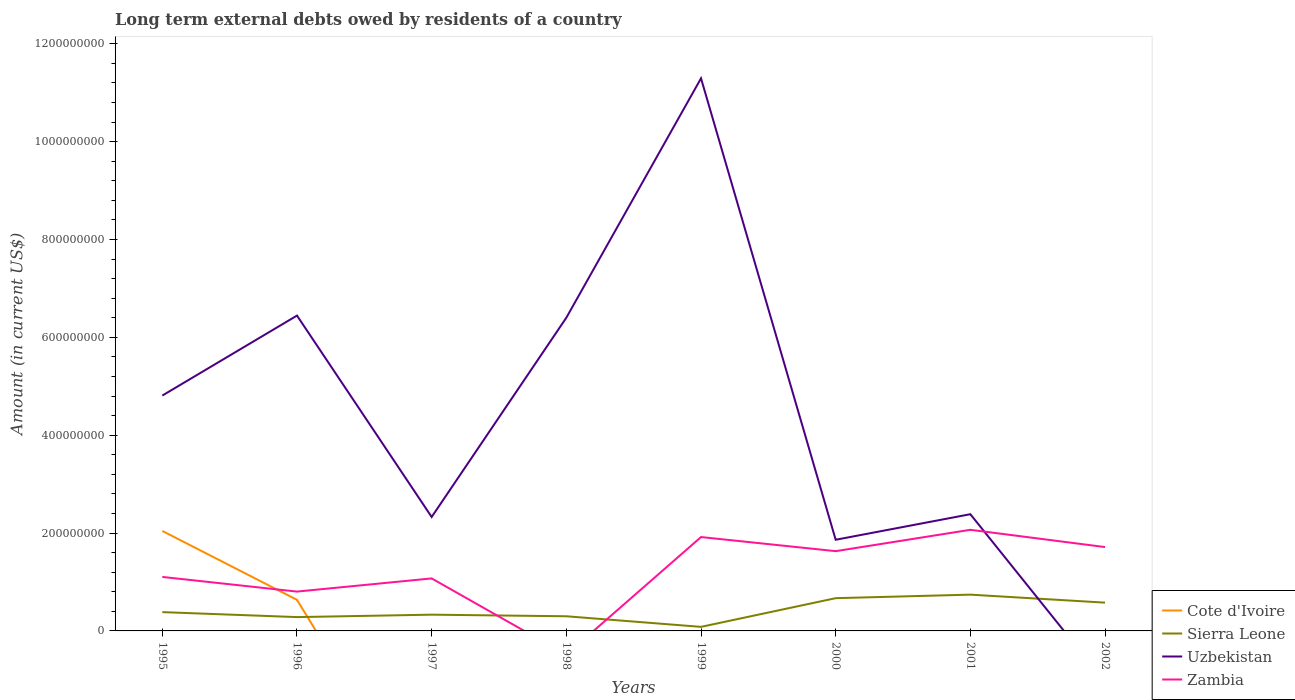How many different coloured lines are there?
Keep it short and to the point. 4. What is the total amount of long-term external debts owed by residents in Zambia in the graph?
Ensure brevity in your answer.  -1.26e+08. What is the difference between the highest and the second highest amount of long-term external debts owed by residents in Uzbekistan?
Your answer should be compact. 1.13e+09. What is the difference between the highest and the lowest amount of long-term external debts owed by residents in Zambia?
Keep it short and to the point. 4. How many lines are there?
Make the answer very short. 4. Are the values on the major ticks of Y-axis written in scientific E-notation?
Offer a very short reply. No. How are the legend labels stacked?
Provide a short and direct response. Vertical. What is the title of the graph?
Provide a short and direct response. Long term external debts owed by residents of a country. What is the label or title of the X-axis?
Offer a terse response. Years. What is the label or title of the Y-axis?
Provide a short and direct response. Amount (in current US$). What is the Amount (in current US$) in Cote d'Ivoire in 1995?
Your answer should be compact. 2.04e+08. What is the Amount (in current US$) in Sierra Leone in 1995?
Your answer should be compact. 3.84e+07. What is the Amount (in current US$) in Uzbekistan in 1995?
Give a very brief answer. 4.81e+08. What is the Amount (in current US$) of Zambia in 1995?
Your answer should be compact. 1.10e+08. What is the Amount (in current US$) of Cote d'Ivoire in 1996?
Keep it short and to the point. 6.35e+07. What is the Amount (in current US$) in Sierra Leone in 1996?
Your answer should be compact. 2.83e+07. What is the Amount (in current US$) of Uzbekistan in 1996?
Offer a terse response. 6.45e+08. What is the Amount (in current US$) of Zambia in 1996?
Offer a very short reply. 8.04e+07. What is the Amount (in current US$) in Sierra Leone in 1997?
Your answer should be compact. 3.32e+07. What is the Amount (in current US$) in Uzbekistan in 1997?
Provide a short and direct response. 2.33e+08. What is the Amount (in current US$) in Zambia in 1997?
Your answer should be compact. 1.07e+08. What is the Amount (in current US$) in Sierra Leone in 1998?
Offer a terse response. 3.00e+07. What is the Amount (in current US$) in Uzbekistan in 1998?
Ensure brevity in your answer.  6.40e+08. What is the Amount (in current US$) in Cote d'Ivoire in 1999?
Ensure brevity in your answer.  0. What is the Amount (in current US$) of Sierra Leone in 1999?
Ensure brevity in your answer.  8.29e+06. What is the Amount (in current US$) in Uzbekistan in 1999?
Your response must be concise. 1.13e+09. What is the Amount (in current US$) of Zambia in 1999?
Ensure brevity in your answer.  1.92e+08. What is the Amount (in current US$) of Cote d'Ivoire in 2000?
Offer a terse response. 0. What is the Amount (in current US$) of Sierra Leone in 2000?
Your response must be concise. 6.69e+07. What is the Amount (in current US$) in Uzbekistan in 2000?
Provide a succinct answer. 1.86e+08. What is the Amount (in current US$) of Zambia in 2000?
Keep it short and to the point. 1.63e+08. What is the Amount (in current US$) in Sierra Leone in 2001?
Provide a short and direct response. 7.41e+07. What is the Amount (in current US$) in Uzbekistan in 2001?
Keep it short and to the point. 2.39e+08. What is the Amount (in current US$) in Zambia in 2001?
Your answer should be compact. 2.07e+08. What is the Amount (in current US$) in Cote d'Ivoire in 2002?
Provide a succinct answer. 0. What is the Amount (in current US$) of Sierra Leone in 2002?
Give a very brief answer. 5.78e+07. What is the Amount (in current US$) of Uzbekistan in 2002?
Offer a very short reply. 0. What is the Amount (in current US$) of Zambia in 2002?
Offer a very short reply. 1.71e+08. Across all years, what is the maximum Amount (in current US$) of Cote d'Ivoire?
Make the answer very short. 2.04e+08. Across all years, what is the maximum Amount (in current US$) in Sierra Leone?
Offer a very short reply. 7.41e+07. Across all years, what is the maximum Amount (in current US$) in Uzbekistan?
Your response must be concise. 1.13e+09. Across all years, what is the maximum Amount (in current US$) of Zambia?
Keep it short and to the point. 2.07e+08. Across all years, what is the minimum Amount (in current US$) in Sierra Leone?
Provide a short and direct response. 8.29e+06. Across all years, what is the minimum Amount (in current US$) in Uzbekistan?
Provide a succinct answer. 0. Across all years, what is the minimum Amount (in current US$) of Zambia?
Give a very brief answer. 0. What is the total Amount (in current US$) of Cote d'Ivoire in the graph?
Provide a succinct answer. 2.68e+08. What is the total Amount (in current US$) of Sierra Leone in the graph?
Your response must be concise. 3.37e+08. What is the total Amount (in current US$) of Uzbekistan in the graph?
Your response must be concise. 3.55e+09. What is the total Amount (in current US$) in Zambia in the graph?
Your response must be concise. 1.03e+09. What is the difference between the Amount (in current US$) of Cote d'Ivoire in 1995 and that in 1996?
Keep it short and to the point. 1.41e+08. What is the difference between the Amount (in current US$) in Sierra Leone in 1995 and that in 1996?
Offer a very short reply. 1.02e+07. What is the difference between the Amount (in current US$) in Uzbekistan in 1995 and that in 1996?
Your answer should be compact. -1.63e+08. What is the difference between the Amount (in current US$) in Zambia in 1995 and that in 1996?
Your answer should be compact. 3.00e+07. What is the difference between the Amount (in current US$) in Sierra Leone in 1995 and that in 1997?
Your response must be concise. 5.22e+06. What is the difference between the Amount (in current US$) of Uzbekistan in 1995 and that in 1997?
Make the answer very short. 2.48e+08. What is the difference between the Amount (in current US$) in Zambia in 1995 and that in 1997?
Your response must be concise. 3.05e+06. What is the difference between the Amount (in current US$) of Sierra Leone in 1995 and that in 1998?
Ensure brevity in your answer.  8.46e+06. What is the difference between the Amount (in current US$) of Uzbekistan in 1995 and that in 1998?
Give a very brief answer. -1.59e+08. What is the difference between the Amount (in current US$) of Sierra Leone in 1995 and that in 1999?
Make the answer very short. 3.01e+07. What is the difference between the Amount (in current US$) of Uzbekistan in 1995 and that in 1999?
Provide a succinct answer. -6.48e+08. What is the difference between the Amount (in current US$) of Zambia in 1995 and that in 1999?
Ensure brevity in your answer.  -8.15e+07. What is the difference between the Amount (in current US$) of Sierra Leone in 1995 and that in 2000?
Offer a terse response. -2.85e+07. What is the difference between the Amount (in current US$) in Uzbekistan in 1995 and that in 2000?
Provide a succinct answer. 2.95e+08. What is the difference between the Amount (in current US$) in Zambia in 1995 and that in 2000?
Provide a short and direct response. -5.27e+07. What is the difference between the Amount (in current US$) of Sierra Leone in 1995 and that in 2001?
Your answer should be compact. -3.57e+07. What is the difference between the Amount (in current US$) in Uzbekistan in 1995 and that in 2001?
Your answer should be compact. 2.42e+08. What is the difference between the Amount (in current US$) of Zambia in 1995 and that in 2001?
Make the answer very short. -9.63e+07. What is the difference between the Amount (in current US$) in Sierra Leone in 1995 and that in 2002?
Your answer should be very brief. -1.94e+07. What is the difference between the Amount (in current US$) of Zambia in 1995 and that in 2002?
Make the answer very short. -6.10e+07. What is the difference between the Amount (in current US$) of Sierra Leone in 1996 and that in 1997?
Offer a very short reply. -4.94e+06. What is the difference between the Amount (in current US$) of Uzbekistan in 1996 and that in 1997?
Ensure brevity in your answer.  4.12e+08. What is the difference between the Amount (in current US$) in Zambia in 1996 and that in 1997?
Make the answer very short. -2.69e+07. What is the difference between the Amount (in current US$) in Sierra Leone in 1996 and that in 1998?
Provide a succinct answer. -1.71e+06. What is the difference between the Amount (in current US$) of Uzbekistan in 1996 and that in 1998?
Your response must be concise. 4.38e+06. What is the difference between the Amount (in current US$) in Sierra Leone in 1996 and that in 1999?
Offer a terse response. 2.00e+07. What is the difference between the Amount (in current US$) of Uzbekistan in 1996 and that in 1999?
Ensure brevity in your answer.  -4.85e+08. What is the difference between the Amount (in current US$) in Zambia in 1996 and that in 1999?
Give a very brief answer. -1.11e+08. What is the difference between the Amount (in current US$) in Sierra Leone in 1996 and that in 2000?
Your answer should be compact. -3.87e+07. What is the difference between the Amount (in current US$) in Uzbekistan in 1996 and that in 2000?
Keep it short and to the point. 4.58e+08. What is the difference between the Amount (in current US$) in Zambia in 1996 and that in 2000?
Your answer should be very brief. -8.26e+07. What is the difference between the Amount (in current US$) in Sierra Leone in 1996 and that in 2001?
Give a very brief answer. -4.59e+07. What is the difference between the Amount (in current US$) in Uzbekistan in 1996 and that in 2001?
Offer a terse response. 4.06e+08. What is the difference between the Amount (in current US$) in Zambia in 1996 and that in 2001?
Keep it short and to the point. -1.26e+08. What is the difference between the Amount (in current US$) in Sierra Leone in 1996 and that in 2002?
Keep it short and to the point. -2.95e+07. What is the difference between the Amount (in current US$) of Zambia in 1996 and that in 2002?
Your answer should be compact. -9.10e+07. What is the difference between the Amount (in current US$) of Sierra Leone in 1997 and that in 1998?
Provide a succinct answer. 3.24e+06. What is the difference between the Amount (in current US$) of Uzbekistan in 1997 and that in 1998?
Ensure brevity in your answer.  -4.07e+08. What is the difference between the Amount (in current US$) of Sierra Leone in 1997 and that in 1999?
Your answer should be very brief. 2.49e+07. What is the difference between the Amount (in current US$) in Uzbekistan in 1997 and that in 1999?
Your response must be concise. -8.97e+08. What is the difference between the Amount (in current US$) in Zambia in 1997 and that in 1999?
Your response must be concise. -8.45e+07. What is the difference between the Amount (in current US$) in Sierra Leone in 1997 and that in 2000?
Provide a succinct answer. -3.37e+07. What is the difference between the Amount (in current US$) in Uzbekistan in 1997 and that in 2000?
Ensure brevity in your answer.  4.66e+07. What is the difference between the Amount (in current US$) of Zambia in 1997 and that in 2000?
Make the answer very short. -5.57e+07. What is the difference between the Amount (in current US$) in Sierra Leone in 1997 and that in 2001?
Provide a short and direct response. -4.09e+07. What is the difference between the Amount (in current US$) of Uzbekistan in 1997 and that in 2001?
Keep it short and to the point. -5.69e+06. What is the difference between the Amount (in current US$) of Zambia in 1997 and that in 2001?
Provide a short and direct response. -9.94e+07. What is the difference between the Amount (in current US$) of Sierra Leone in 1997 and that in 2002?
Offer a terse response. -2.46e+07. What is the difference between the Amount (in current US$) of Zambia in 1997 and that in 2002?
Make the answer very short. -6.41e+07. What is the difference between the Amount (in current US$) of Sierra Leone in 1998 and that in 1999?
Ensure brevity in your answer.  2.17e+07. What is the difference between the Amount (in current US$) in Uzbekistan in 1998 and that in 1999?
Offer a very short reply. -4.89e+08. What is the difference between the Amount (in current US$) in Sierra Leone in 1998 and that in 2000?
Your answer should be compact. -3.70e+07. What is the difference between the Amount (in current US$) of Uzbekistan in 1998 and that in 2000?
Provide a short and direct response. 4.54e+08. What is the difference between the Amount (in current US$) in Sierra Leone in 1998 and that in 2001?
Your response must be concise. -4.42e+07. What is the difference between the Amount (in current US$) of Uzbekistan in 1998 and that in 2001?
Make the answer very short. 4.02e+08. What is the difference between the Amount (in current US$) of Sierra Leone in 1998 and that in 2002?
Your response must be concise. -2.78e+07. What is the difference between the Amount (in current US$) in Sierra Leone in 1999 and that in 2000?
Provide a short and direct response. -5.87e+07. What is the difference between the Amount (in current US$) in Uzbekistan in 1999 and that in 2000?
Offer a very short reply. 9.43e+08. What is the difference between the Amount (in current US$) of Zambia in 1999 and that in 2000?
Your answer should be very brief. 2.88e+07. What is the difference between the Amount (in current US$) in Sierra Leone in 1999 and that in 2001?
Offer a very short reply. -6.59e+07. What is the difference between the Amount (in current US$) of Uzbekistan in 1999 and that in 2001?
Keep it short and to the point. 8.91e+08. What is the difference between the Amount (in current US$) of Zambia in 1999 and that in 2001?
Provide a succinct answer. -1.48e+07. What is the difference between the Amount (in current US$) of Sierra Leone in 1999 and that in 2002?
Offer a very short reply. -4.95e+07. What is the difference between the Amount (in current US$) of Zambia in 1999 and that in 2002?
Offer a very short reply. 2.05e+07. What is the difference between the Amount (in current US$) in Sierra Leone in 2000 and that in 2001?
Provide a short and direct response. -7.21e+06. What is the difference between the Amount (in current US$) in Uzbekistan in 2000 and that in 2001?
Ensure brevity in your answer.  -5.22e+07. What is the difference between the Amount (in current US$) of Zambia in 2000 and that in 2001?
Your answer should be very brief. -4.37e+07. What is the difference between the Amount (in current US$) in Sierra Leone in 2000 and that in 2002?
Offer a terse response. 9.15e+06. What is the difference between the Amount (in current US$) in Zambia in 2000 and that in 2002?
Your answer should be very brief. -8.37e+06. What is the difference between the Amount (in current US$) in Sierra Leone in 2001 and that in 2002?
Your answer should be very brief. 1.64e+07. What is the difference between the Amount (in current US$) in Zambia in 2001 and that in 2002?
Provide a short and direct response. 3.53e+07. What is the difference between the Amount (in current US$) in Cote d'Ivoire in 1995 and the Amount (in current US$) in Sierra Leone in 1996?
Ensure brevity in your answer.  1.76e+08. What is the difference between the Amount (in current US$) of Cote d'Ivoire in 1995 and the Amount (in current US$) of Uzbekistan in 1996?
Keep it short and to the point. -4.40e+08. What is the difference between the Amount (in current US$) of Cote d'Ivoire in 1995 and the Amount (in current US$) of Zambia in 1996?
Ensure brevity in your answer.  1.24e+08. What is the difference between the Amount (in current US$) of Sierra Leone in 1995 and the Amount (in current US$) of Uzbekistan in 1996?
Offer a very short reply. -6.06e+08. What is the difference between the Amount (in current US$) in Sierra Leone in 1995 and the Amount (in current US$) in Zambia in 1996?
Offer a very short reply. -4.20e+07. What is the difference between the Amount (in current US$) of Uzbekistan in 1995 and the Amount (in current US$) of Zambia in 1996?
Ensure brevity in your answer.  4.01e+08. What is the difference between the Amount (in current US$) in Cote d'Ivoire in 1995 and the Amount (in current US$) in Sierra Leone in 1997?
Provide a short and direct response. 1.71e+08. What is the difference between the Amount (in current US$) in Cote d'Ivoire in 1995 and the Amount (in current US$) in Uzbekistan in 1997?
Provide a succinct answer. -2.85e+07. What is the difference between the Amount (in current US$) in Cote d'Ivoire in 1995 and the Amount (in current US$) in Zambia in 1997?
Your response must be concise. 9.70e+07. What is the difference between the Amount (in current US$) in Sierra Leone in 1995 and the Amount (in current US$) in Uzbekistan in 1997?
Offer a very short reply. -1.94e+08. What is the difference between the Amount (in current US$) of Sierra Leone in 1995 and the Amount (in current US$) of Zambia in 1997?
Offer a very short reply. -6.89e+07. What is the difference between the Amount (in current US$) in Uzbekistan in 1995 and the Amount (in current US$) in Zambia in 1997?
Offer a terse response. 3.74e+08. What is the difference between the Amount (in current US$) of Cote d'Ivoire in 1995 and the Amount (in current US$) of Sierra Leone in 1998?
Provide a short and direct response. 1.74e+08. What is the difference between the Amount (in current US$) of Cote d'Ivoire in 1995 and the Amount (in current US$) of Uzbekistan in 1998?
Give a very brief answer. -4.36e+08. What is the difference between the Amount (in current US$) of Sierra Leone in 1995 and the Amount (in current US$) of Uzbekistan in 1998?
Your response must be concise. -6.02e+08. What is the difference between the Amount (in current US$) of Cote d'Ivoire in 1995 and the Amount (in current US$) of Sierra Leone in 1999?
Make the answer very short. 1.96e+08. What is the difference between the Amount (in current US$) of Cote d'Ivoire in 1995 and the Amount (in current US$) of Uzbekistan in 1999?
Offer a very short reply. -9.25e+08. What is the difference between the Amount (in current US$) of Cote d'Ivoire in 1995 and the Amount (in current US$) of Zambia in 1999?
Ensure brevity in your answer.  1.25e+07. What is the difference between the Amount (in current US$) in Sierra Leone in 1995 and the Amount (in current US$) in Uzbekistan in 1999?
Offer a very short reply. -1.09e+09. What is the difference between the Amount (in current US$) of Sierra Leone in 1995 and the Amount (in current US$) of Zambia in 1999?
Provide a short and direct response. -1.53e+08. What is the difference between the Amount (in current US$) of Uzbekistan in 1995 and the Amount (in current US$) of Zambia in 1999?
Offer a terse response. 2.89e+08. What is the difference between the Amount (in current US$) of Cote d'Ivoire in 1995 and the Amount (in current US$) of Sierra Leone in 2000?
Ensure brevity in your answer.  1.37e+08. What is the difference between the Amount (in current US$) of Cote d'Ivoire in 1995 and the Amount (in current US$) of Uzbekistan in 2000?
Provide a succinct answer. 1.80e+07. What is the difference between the Amount (in current US$) of Cote d'Ivoire in 1995 and the Amount (in current US$) of Zambia in 2000?
Keep it short and to the point. 4.13e+07. What is the difference between the Amount (in current US$) in Sierra Leone in 1995 and the Amount (in current US$) in Uzbekistan in 2000?
Give a very brief answer. -1.48e+08. What is the difference between the Amount (in current US$) in Sierra Leone in 1995 and the Amount (in current US$) in Zambia in 2000?
Make the answer very short. -1.25e+08. What is the difference between the Amount (in current US$) of Uzbekistan in 1995 and the Amount (in current US$) of Zambia in 2000?
Make the answer very short. 3.18e+08. What is the difference between the Amount (in current US$) in Cote d'Ivoire in 1995 and the Amount (in current US$) in Sierra Leone in 2001?
Provide a short and direct response. 1.30e+08. What is the difference between the Amount (in current US$) of Cote d'Ivoire in 1995 and the Amount (in current US$) of Uzbekistan in 2001?
Your response must be concise. -3.42e+07. What is the difference between the Amount (in current US$) in Cote d'Ivoire in 1995 and the Amount (in current US$) in Zambia in 2001?
Your answer should be compact. -2.31e+06. What is the difference between the Amount (in current US$) in Sierra Leone in 1995 and the Amount (in current US$) in Uzbekistan in 2001?
Ensure brevity in your answer.  -2.00e+08. What is the difference between the Amount (in current US$) in Sierra Leone in 1995 and the Amount (in current US$) in Zambia in 2001?
Give a very brief answer. -1.68e+08. What is the difference between the Amount (in current US$) of Uzbekistan in 1995 and the Amount (in current US$) of Zambia in 2001?
Your answer should be compact. 2.74e+08. What is the difference between the Amount (in current US$) of Cote d'Ivoire in 1995 and the Amount (in current US$) of Sierra Leone in 2002?
Give a very brief answer. 1.47e+08. What is the difference between the Amount (in current US$) of Cote d'Ivoire in 1995 and the Amount (in current US$) of Zambia in 2002?
Your answer should be very brief. 3.30e+07. What is the difference between the Amount (in current US$) in Sierra Leone in 1995 and the Amount (in current US$) in Zambia in 2002?
Give a very brief answer. -1.33e+08. What is the difference between the Amount (in current US$) of Uzbekistan in 1995 and the Amount (in current US$) of Zambia in 2002?
Your response must be concise. 3.10e+08. What is the difference between the Amount (in current US$) in Cote d'Ivoire in 1996 and the Amount (in current US$) in Sierra Leone in 1997?
Keep it short and to the point. 3.03e+07. What is the difference between the Amount (in current US$) in Cote d'Ivoire in 1996 and the Amount (in current US$) in Uzbekistan in 1997?
Provide a succinct answer. -1.69e+08. What is the difference between the Amount (in current US$) of Cote d'Ivoire in 1996 and the Amount (in current US$) of Zambia in 1997?
Your response must be concise. -4.38e+07. What is the difference between the Amount (in current US$) in Sierra Leone in 1996 and the Amount (in current US$) in Uzbekistan in 1997?
Ensure brevity in your answer.  -2.05e+08. What is the difference between the Amount (in current US$) in Sierra Leone in 1996 and the Amount (in current US$) in Zambia in 1997?
Your response must be concise. -7.91e+07. What is the difference between the Amount (in current US$) in Uzbekistan in 1996 and the Amount (in current US$) in Zambia in 1997?
Your answer should be very brief. 5.37e+08. What is the difference between the Amount (in current US$) of Cote d'Ivoire in 1996 and the Amount (in current US$) of Sierra Leone in 1998?
Your response must be concise. 3.36e+07. What is the difference between the Amount (in current US$) of Cote d'Ivoire in 1996 and the Amount (in current US$) of Uzbekistan in 1998?
Give a very brief answer. -5.77e+08. What is the difference between the Amount (in current US$) in Sierra Leone in 1996 and the Amount (in current US$) in Uzbekistan in 1998?
Your answer should be compact. -6.12e+08. What is the difference between the Amount (in current US$) of Cote d'Ivoire in 1996 and the Amount (in current US$) of Sierra Leone in 1999?
Ensure brevity in your answer.  5.53e+07. What is the difference between the Amount (in current US$) of Cote d'Ivoire in 1996 and the Amount (in current US$) of Uzbekistan in 1999?
Your answer should be very brief. -1.07e+09. What is the difference between the Amount (in current US$) of Cote d'Ivoire in 1996 and the Amount (in current US$) of Zambia in 1999?
Your answer should be very brief. -1.28e+08. What is the difference between the Amount (in current US$) in Sierra Leone in 1996 and the Amount (in current US$) in Uzbekistan in 1999?
Provide a short and direct response. -1.10e+09. What is the difference between the Amount (in current US$) in Sierra Leone in 1996 and the Amount (in current US$) in Zambia in 1999?
Keep it short and to the point. -1.64e+08. What is the difference between the Amount (in current US$) of Uzbekistan in 1996 and the Amount (in current US$) of Zambia in 1999?
Make the answer very short. 4.53e+08. What is the difference between the Amount (in current US$) of Cote d'Ivoire in 1996 and the Amount (in current US$) of Sierra Leone in 2000?
Offer a very short reply. -3.40e+06. What is the difference between the Amount (in current US$) of Cote d'Ivoire in 1996 and the Amount (in current US$) of Uzbekistan in 2000?
Provide a short and direct response. -1.23e+08. What is the difference between the Amount (in current US$) of Cote d'Ivoire in 1996 and the Amount (in current US$) of Zambia in 2000?
Ensure brevity in your answer.  -9.95e+07. What is the difference between the Amount (in current US$) in Sierra Leone in 1996 and the Amount (in current US$) in Uzbekistan in 2000?
Offer a terse response. -1.58e+08. What is the difference between the Amount (in current US$) in Sierra Leone in 1996 and the Amount (in current US$) in Zambia in 2000?
Your answer should be compact. -1.35e+08. What is the difference between the Amount (in current US$) of Uzbekistan in 1996 and the Amount (in current US$) of Zambia in 2000?
Keep it short and to the point. 4.82e+08. What is the difference between the Amount (in current US$) in Cote d'Ivoire in 1996 and the Amount (in current US$) in Sierra Leone in 2001?
Your answer should be compact. -1.06e+07. What is the difference between the Amount (in current US$) of Cote d'Ivoire in 1996 and the Amount (in current US$) of Uzbekistan in 2001?
Your answer should be compact. -1.75e+08. What is the difference between the Amount (in current US$) of Cote d'Ivoire in 1996 and the Amount (in current US$) of Zambia in 2001?
Provide a succinct answer. -1.43e+08. What is the difference between the Amount (in current US$) of Sierra Leone in 1996 and the Amount (in current US$) of Uzbekistan in 2001?
Offer a terse response. -2.10e+08. What is the difference between the Amount (in current US$) of Sierra Leone in 1996 and the Amount (in current US$) of Zambia in 2001?
Your response must be concise. -1.78e+08. What is the difference between the Amount (in current US$) in Uzbekistan in 1996 and the Amount (in current US$) in Zambia in 2001?
Provide a succinct answer. 4.38e+08. What is the difference between the Amount (in current US$) of Cote d'Ivoire in 1996 and the Amount (in current US$) of Sierra Leone in 2002?
Keep it short and to the point. 5.75e+06. What is the difference between the Amount (in current US$) in Cote d'Ivoire in 1996 and the Amount (in current US$) in Zambia in 2002?
Give a very brief answer. -1.08e+08. What is the difference between the Amount (in current US$) of Sierra Leone in 1996 and the Amount (in current US$) of Zambia in 2002?
Make the answer very short. -1.43e+08. What is the difference between the Amount (in current US$) in Uzbekistan in 1996 and the Amount (in current US$) in Zambia in 2002?
Offer a terse response. 4.73e+08. What is the difference between the Amount (in current US$) of Sierra Leone in 1997 and the Amount (in current US$) of Uzbekistan in 1998?
Your answer should be very brief. -6.07e+08. What is the difference between the Amount (in current US$) of Sierra Leone in 1997 and the Amount (in current US$) of Uzbekistan in 1999?
Provide a short and direct response. -1.10e+09. What is the difference between the Amount (in current US$) in Sierra Leone in 1997 and the Amount (in current US$) in Zambia in 1999?
Keep it short and to the point. -1.59e+08. What is the difference between the Amount (in current US$) in Uzbekistan in 1997 and the Amount (in current US$) in Zambia in 1999?
Offer a terse response. 4.10e+07. What is the difference between the Amount (in current US$) in Sierra Leone in 1997 and the Amount (in current US$) in Uzbekistan in 2000?
Offer a very short reply. -1.53e+08. What is the difference between the Amount (in current US$) of Sierra Leone in 1997 and the Amount (in current US$) of Zambia in 2000?
Offer a terse response. -1.30e+08. What is the difference between the Amount (in current US$) of Uzbekistan in 1997 and the Amount (in current US$) of Zambia in 2000?
Your response must be concise. 6.99e+07. What is the difference between the Amount (in current US$) of Sierra Leone in 1997 and the Amount (in current US$) of Uzbekistan in 2001?
Your answer should be very brief. -2.05e+08. What is the difference between the Amount (in current US$) in Sierra Leone in 1997 and the Amount (in current US$) in Zambia in 2001?
Offer a terse response. -1.73e+08. What is the difference between the Amount (in current US$) in Uzbekistan in 1997 and the Amount (in current US$) in Zambia in 2001?
Ensure brevity in your answer.  2.62e+07. What is the difference between the Amount (in current US$) of Sierra Leone in 1997 and the Amount (in current US$) of Zambia in 2002?
Ensure brevity in your answer.  -1.38e+08. What is the difference between the Amount (in current US$) in Uzbekistan in 1997 and the Amount (in current US$) in Zambia in 2002?
Provide a short and direct response. 6.15e+07. What is the difference between the Amount (in current US$) in Sierra Leone in 1998 and the Amount (in current US$) in Uzbekistan in 1999?
Your response must be concise. -1.10e+09. What is the difference between the Amount (in current US$) of Sierra Leone in 1998 and the Amount (in current US$) of Zambia in 1999?
Ensure brevity in your answer.  -1.62e+08. What is the difference between the Amount (in current US$) of Uzbekistan in 1998 and the Amount (in current US$) of Zambia in 1999?
Your response must be concise. 4.48e+08. What is the difference between the Amount (in current US$) of Sierra Leone in 1998 and the Amount (in current US$) of Uzbekistan in 2000?
Offer a very short reply. -1.56e+08. What is the difference between the Amount (in current US$) in Sierra Leone in 1998 and the Amount (in current US$) in Zambia in 2000?
Give a very brief answer. -1.33e+08. What is the difference between the Amount (in current US$) in Uzbekistan in 1998 and the Amount (in current US$) in Zambia in 2000?
Your answer should be very brief. 4.77e+08. What is the difference between the Amount (in current US$) of Sierra Leone in 1998 and the Amount (in current US$) of Uzbekistan in 2001?
Offer a very short reply. -2.09e+08. What is the difference between the Amount (in current US$) in Sierra Leone in 1998 and the Amount (in current US$) in Zambia in 2001?
Offer a very short reply. -1.77e+08. What is the difference between the Amount (in current US$) of Uzbekistan in 1998 and the Amount (in current US$) of Zambia in 2001?
Offer a terse response. 4.33e+08. What is the difference between the Amount (in current US$) in Sierra Leone in 1998 and the Amount (in current US$) in Zambia in 2002?
Give a very brief answer. -1.41e+08. What is the difference between the Amount (in current US$) of Uzbekistan in 1998 and the Amount (in current US$) of Zambia in 2002?
Your answer should be very brief. 4.69e+08. What is the difference between the Amount (in current US$) in Sierra Leone in 1999 and the Amount (in current US$) in Uzbekistan in 2000?
Your answer should be very brief. -1.78e+08. What is the difference between the Amount (in current US$) of Sierra Leone in 1999 and the Amount (in current US$) of Zambia in 2000?
Your answer should be compact. -1.55e+08. What is the difference between the Amount (in current US$) of Uzbekistan in 1999 and the Amount (in current US$) of Zambia in 2000?
Your answer should be compact. 9.66e+08. What is the difference between the Amount (in current US$) in Sierra Leone in 1999 and the Amount (in current US$) in Uzbekistan in 2001?
Give a very brief answer. -2.30e+08. What is the difference between the Amount (in current US$) of Sierra Leone in 1999 and the Amount (in current US$) of Zambia in 2001?
Give a very brief answer. -1.98e+08. What is the difference between the Amount (in current US$) of Uzbekistan in 1999 and the Amount (in current US$) of Zambia in 2001?
Your response must be concise. 9.23e+08. What is the difference between the Amount (in current US$) in Sierra Leone in 1999 and the Amount (in current US$) in Zambia in 2002?
Offer a terse response. -1.63e+08. What is the difference between the Amount (in current US$) of Uzbekistan in 1999 and the Amount (in current US$) of Zambia in 2002?
Your response must be concise. 9.58e+08. What is the difference between the Amount (in current US$) of Sierra Leone in 2000 and the Amount (in current US$) of Uzbekistan in 2001?
Give a very brief answer. -1.72e+08. What is the difference between the Amount (in current US$) of Sierra Leone in 2000 and the Amount (in current US$) of Zambia in 2001?
Your answer should be very brief. -1.40e+08. What is the difference between the Amount (in current US$) in Uzbekistan in 2000 and the Amount (in current US$) in Zambia in 2001?
Your response must be concise. -2.03e+07. What is the difference between the Amount (in current US$) of Sierra Leone in 2000 and the Amount (in current US$) of Zambia in 2002?
Offer a very short reply. -1.04e+08. What is the difference between the Amount (in current US$) of Uzbekistan in 2000 and the Amount (in current US$) of Zambia in 2002?
Keep it short and to the point. 1.49e+07. What is the difference between the Amount (in current US$) in Sierra Leone in 2001 and the Amount (in current US$) in Zambia in 2002?
Your answer should be compact. -9.72e+07. What is the difference between the Amount (in current US$) in Uzbekistan in 2001 and the Amount (in current US$) in Zambia in 2002?
Your answer should be compact. 6.72e+07. What is the average Amount (in current US$) of Cote d'Ivoire per year?
Provide a succinct answer. 3.35e+07. What is the average Amount (in current US$) of Sierra Leone per year?
Ensure brevity in your answer.  4.21e+07. What is the average Amount (in current US$) in Uzbekistan per year?
Make the answer very short. 4.44e+08. What is the average Amount (in current US$) of Zambia per year?
Your answer should be compact. 1.29e+08. In the year 1995, what is the difference between the Amount (in current US$) in Cote d'Ivoire and Amount (in current US$) in Sierra Leone?
Keep it short and to the point. 1.66e+08. In the year 1995, what is the difference between the Amount (in current US$) of Cote d'Ivoire and Amount (in current US$) of Uzbekistan?
Ensure brevity in your answer.  -2.77e+08. In the year 1995, what is the difference between the Amount (in current US$) in Cote d'Ivoire and Amount (in current US$) in Zambia?
Offer a very short reply. 9.40e+07. In the year 1995, what is the difference between the Amount (in current US$) in Sierra Leone and Amount (in current US$) in Uzbekistan?
Make the answer very short. -4.43e+08. In the year 1995, what is the difference between the Amount (in current US$) of Sierra Leone and Amount (in current US$) of Zambia?
Your answer should be compact. -7.19e+07. In the year 1995, what is the difference between the Amount (in current US$) of Uzbekistan and Amount (in current US$) of Zambia?
Your response must be concise. 3.71e+08. In the year 1996, what is the difference between the Amount (in current US$) of Cote d'Ivoire and Amount (in current US$) of Sierra Leone?
Your answer should be very brief. 3.53e+07. In the year 1996, what is the difference between the Amount (in current US$) of Cote d'Ivoire and Amount (in current US$) of Uzbekistan?
Make the answer very short. -5.81e+08. In the year 1996, what is the difference between the Amount (in current US$) of Cote d'Ivoire and Amount (in current US$) of Zambia?
Your response must be concise. -1.69e+07. In the year 1996, what is the difference between the Amount (in current US$) in Sierra Leone and Amount (in current US$) in Uzbekistan?
Keep it short and to the point. -6.16e+08. In the year 1996, what is the difference between the Amount (in current US$) of Sierra Leone and Amount (in current US$) of Zambia?
Make the answer very short. -5.21e+07. In the year 1996, what is the difference between the Amount (in current US$) of Uzbekistan and Amount (in current US$) of Zambia?
Your answer should be compact. 5.64e+08. In the year 1997, what is the difference between the Amount (in current US$) of Sierra Leone and Amount (in current US$) of Uzbekistan?
Your answer should be compact. -2.00e+08. In the year 1997, what is the difference between the Amount (in current US$) of Sierra Leone and Amount (in current US$) of Zambia?
Provide a short and direct response. -7.41e+07. In the year 1997, what is the difference between the Amount (in current US$) of Uzbekistan and Amount (in current US$) of Zambia?
Ensure brevity in your answer.  1.26e+08. In the year 1998, what is the difference between the Amount (in current US$) in Sierra Leone and Amount (in current US$) in Uzbekistan?
Ensure brevity in your answer.  -6.10e+08. In the year 1999, what is the difference between the Amount (in current US$) of Sierra Leone and Amount (in current US$) of Uzbekistan?
Offer a very short reply. -1.12e+09. In the year 1999, what is the difference between the Amount (in current US$) of Sierra Leone and Amount (in current US$) of Zambia?
Your response must be concise. -1.84e+08. In the year 1999, what is the difference between the Amount (in current US$) in Uzbekistan and Amount (in current US$) in Zambia?
Your answer should be very brief. 9.38e+08. In the year 2000, what is the difference between the Amount (in current US$) in Sierra Leone and Amount (in current US$) in Uzbekistan?
Provide a short and direct response. -1.19e+08. In the year 2000, what is the difference between the Amount (in current US$) of Sierra Leone and Amount (in current US$) of Zambia?
Your answer should be very brief. -9.61e+07. In the year 2000, what is the difference between the Amount (in current US$) in Uzbekistan and Amount (in current US$) in Zambia?
Give a very brief answer. 2.33e+07. In the year 2001, what is the difference between the Amount (in current US$) of Sierra Leone and Amount (in current US$) of Uzbekistan?
Offer a very short reply. -1.64e+08. In the year 2001, what is the difference between the Amount (in current US$) in Sierra Leone and Amount (in current US$) in Zambia?
Your answer should be compact. -1.33e+08. In the year 2001, what is the difference between the Amount (in current US$) in Uzbekistan and Amount (in current US$) in Zambia?
Your answer should be compact. 3.19e+07. In the year 2002, what is the difference between the Amount (in current US$) in Sierra Leone and Amount (in current US$) in Zambia?
Your answer should be very brief. -1.14e+08. What is the ratio of the Amount (in current US$) of Cote d'Ivoire in 1995 to that in 1996?
Offer a terse response. 3.22. What is the ratio of the Amount (in current US$) in Sierra Leone in 1995 to that in 1996?
Provide a short and direct response. 1.36. What is the ratio of the Amount (in current US$) of Uzbekistan in 1995 to that in 1996?
Provide a short and direct response. 0.75. What is the ratio of the Amount (in current US$) in Zambia in 1995 to that in 1996?
Keep it short and to the point. 1.37. What is the ratio of the Amount (in current US$) of Sierra Leone in 1995 to that in 1997?
Provide a succinct answer. 1.16. What is the ratio of the Amount (in current US$) in Uzbekistan in 1995 to that in 1997?
Your answer should be very brief. 2.07. What is the ratio of the Amount (in current US$) in Zambia in 1995 to that in 1997?
Ensure brevity in your answer.  1.03. What is the ratio of the Amount (in current US$) of Sierra Leone in 1995 to that in 1998?
Ensure brevity in your answer.  1.28. What is the ratio of the Amount (in current US$) of Uzbekistan in 1995 to that in 1998?
Make the answer very short. 0.75. What is the ratio of the Amount (in current US$) of Sierra Leone in 1995 to that in 1999?
Your answer should be very brief. 4.64. What is the ratio of the Amount (in current US$) of Uzbekistan in 1995 to that in 1999?
Your answer should be very brief. 0.43. What is the ratio of the Amount (in current US$) in Zambia in 1995 to that in 1999?
Provide a short and direct response. 0.58. What is the ratio of the Amount (in current US$) of Sierra Leone in 1995 to that in 2000?
Your answer should be very brief. 0.57. What is the ratio of the Amount (in current US$) of Uzbekistan in 1995 to that in 2000?
Provide a short and direct response. 2.58. What is the ratio of the Amount (in current US$) in Zambia in 1995 to that in 2000?
Provide a succinct answer. 0.68. What is the ratio of the Amount (in current US$) of Sierra Leone in 1995 to that in 2001?
Make the answer very short. 0.52. What is the ratio of the Amount (in current US$) in Uzbekistan in 1995 to that in 2001?
Your answer should be compact. 2.02. What is the ratio of the Amount (in current US$) in Zambia in 1995 to that in 2001?
Provide a short and direct response. 0.53. What is the ratio of the Amount (in current US$) of Sierra Leone in 1995 to that in 2002?
Make the answer very short. 0.66. What is the ratio of the Amount (in current US$) of Zambia in 1995 to that in 2002?
Ensure brevity in your answer.  0.64. What is the ratio of the Amount (in current US$) in Sierra Leone in 1996 to that in 1997?
Your response must be concise. 0.85. What is the ratio of the Amount (in current US$) in Uzbekistan in 1996 to that in 1997?
Your response must be concise. 2.77. What is the ratio of the Amount (in current US$) in Zambia in 1996 to that in 1997?
Offer a very short reply. 0.75. What is the ratio of the Amount (in current US$) in Sierra Leone in 1996 to that in 1998?
Your answer should be compact. 0.94. What is the ratio of the Amount (in current US$) in Uzbekistan in 1996 to that in 1998?
Ensure brevity in your answer.  1.01. What is the ratio of the Amount (in current US$) in Sierra Leone in 1996 to that in 1999?
Your answer should be compact. 3.41. What is the ratio of the Amount (in current US$) in Uzbekistan in 1996 to that in 1999?
Your response must be concise. 0.57. What is the ratio of the Amount (in current US$) of Zambia in 1996 to that in 1999?
Give a very brief answer. 0.42. What is the ratio of the Amount (in current US$) in Sierra Leone in 1996 to that in 2000?
Provide a short and direct response. 0.42. What is the ratio of the Amount (in current US$) of Uzbekistan in 1996 to that in 2000?
Your answer should be very brief. 3.46. What is the ratio of the Amount (in current US$) in Zambia in 1996 to that in 2000?
Your response must be concise. 0.49. What is the ratio of the Amount (in current US$) of Sierra Leone in 1996 to that in 2001?
Give a very brief answer. 0.38. What is the ratio of the Amount (in current US$) in Uzbekistan in 1996 to that in 2001?
Your answer should be compact. 2.7. What is the ratio of the Amount (in current US$) in Zambia in 1996 to that in 2001?
Offer a very short reply. 0.39. What is the ratio of the Amount (in current US$) in Sierra Leone in 1996 to that in 2002?
Make the answer very short. 0.49. What is the ratio of the Amount (in current US$) in Zambia in 1996 to that in 2002?
Your answer should be very brief. 0.47. What is the ratio of the Amount (in current US$) in Sierra Leone in 1997 to that in 1998?
Give a very brief answer. 1.11. What is the ratio of the Amount (in current US$) of Uzbekistan in 1997 to that in 1998?
Your answer should be compact. 0.36. What is the ratio of the Amount (in current US$) in Sierra Leone in 1997 to that in 1999?
Give a very brief answer. 4.01. What is the ratio of the Amount (in current US$) in Uzbekistan in 1997 to that in 1999?
Provide a short and direct response. 0.21. What is the ratio of the Amount (in current US$) in Zambia in 1997 to that in 1999?
Provide a succinct answer. 0.56. What is the ratio of the Amount (in current US$) in Sierra Leone in 1997 to that in 2000?
Ensure brevity in your answer.  0.5. What is the ratio of the Amount (in current US$) in Uzbekistan in 1997 to that in 2000?
Your answer should be compact. 1.25. What is the ratio of the Amount (in current US$) of Zambia in 1997 to that in 2000?
Ensure brevity in your answer.  0.66. What is the ratio of the Amount (in current US$) of Sierra Leone in 1997 to that in 2001?
Your answer should be very brief. 0.45. What is the ratio of the Amount (in current US$) in Uzbekistan in 1997 to that in 2001?
Provide a succinct answer. 0.98. What is the ratio of the Amount (in current US$) in Zambia in 1997 to that in 2001?
Offer a very short reply. 0.52. What is the ratio of the Amount (in current US$) in Sierra Leone in 1997 to that in 2002?
Make the answer very short. 0.57. What is the ratio of the Amount (in current US$) in Zambia in 1997 to that in 2002?
Offer a terse response. 0.63. What is the ratio of the Amount (in current US$) in Sierra Leone in 1998 to that in 1999?
Your answer should be very brief. 3.62. What is the ratio of the Amount (in current US$) of Uzbekistan in 1998 to that in 1999?
Your response must be concise. 0.57. What is the ratio of the Amount (in current US$) of Sierra Leone in 1998 to that in 2000?
Your answer should be compact. 0.45. What is the ratio of the Amount (in current US$) in Uzbekistan in 1998 to that in 2000?
Your response must be concise. 3.44. What is the ratio of the Amount (in current US$) in Sierra Leone in 1998 to that in 2001?
Offer a very short reply. 0.4. What is the ratio of the Amount (in current US$) of Uzbekistan in 1998 to that in 2001?
Keep it short and to the point. 2.68. What is the ratio of the Amount (in current US$) of Sierra Leone in 1998 to that in 2002?
Provide a succinct answer. 0.52. What is the ratio of the Amount (in current US$) of Sierra Leone in 1999 to that in 2000?
Keep it short and to the point. 0.12. What is the ratio of the Amount (in current US$) of Uzbekistan in 1999 to that in 2000?
Offer a very short reply. 6.06. What is the ratio of the Amount (in current US$) in Zambia in 1999 to that in 2000?
Keep it short and to the point. 1.18. What is the ratio of the Amount (in current US$) in Sierra Leone in 1999 to that in 2001?
Offer a very short reply. 0.11. What is the ratio of the Amount (in current US$) in Uzbekistan in 1999 to that in 2001?
Your answer should be very brief. 4.73. What is the ratio of the Amount (in current US$) in Zambia in 1999 to that in 2001?
Your answer should be very brief. 0.93. What is the ratio of the Amount (in current US$) in Sierra Leone in 1999 to that in 2002?
Your answer should be compact. 0.14. What is the ratio of the Amount (in current US$) of Zambia in 1999 to that in 2002?
Keep it short and to the point. 1.12. What is the ratio of the Amount (in current US$) in Sierra Leone in 2000 to that in 2001?
Provide a short and direct response. 0.9. What is the ratio of the Amount (in current US$) of Uzbekistan in 2000 to that in 2001?
Give a very brief answer. 0.78. What is the ratio of the Amount (in current US$) of Zambia in 2000 to that in 2001?
Your response must be concise. 0.79. What is the ratio of the Amount (in current US$) of Sierra Leone in 2000 to that in 2002?
Your answer should be compact. 1.16. What is the ratio of the Amount (in current US$) in Zambia in 2000 to that in 2002?
Offer a terse response. 0.95. What is the ratio of the Amount (in current US$) of Sierra Leone in 2001 to that in 2002?
Offer a terse response. 1.28. What is the ratio of the Amount (in current US$) of Zambia in 2001 to that in 2002?
Your answer should be very brief. 1.21. What is the difference between the highest and the second highest Amount (in current US$) in Sierra Leone?
Offer a very short reply. 7.21e+06. What is the difference between the highest and the second highest Amount (in current US$) in Uzbekistan?
Your answer should be very brief. 4.85e+08. What is the difference between the highest and the second highest Amount (in current US$) in Zambia?
Provide a succinct answer. 1.48e+07. What is the difference between the highest and the lowest Amount (in current US$) in Cote d'Ivoire?
Keep it short and to the point. 2.04e+08. What is the difference between the highest and the lowest Amount (in current US$) of Sierra Leone?
Your answer should be very brief. 6.59e+07. What is the difference between the highest and the lowest Amount (in current US$) in Uzbekistan?
Your response must be concise. 1.13e+09. What is the difference between the highest and the lowest Amount (in current US$) in Zambia?
Provide a succinct answer. 2.07e+08. 